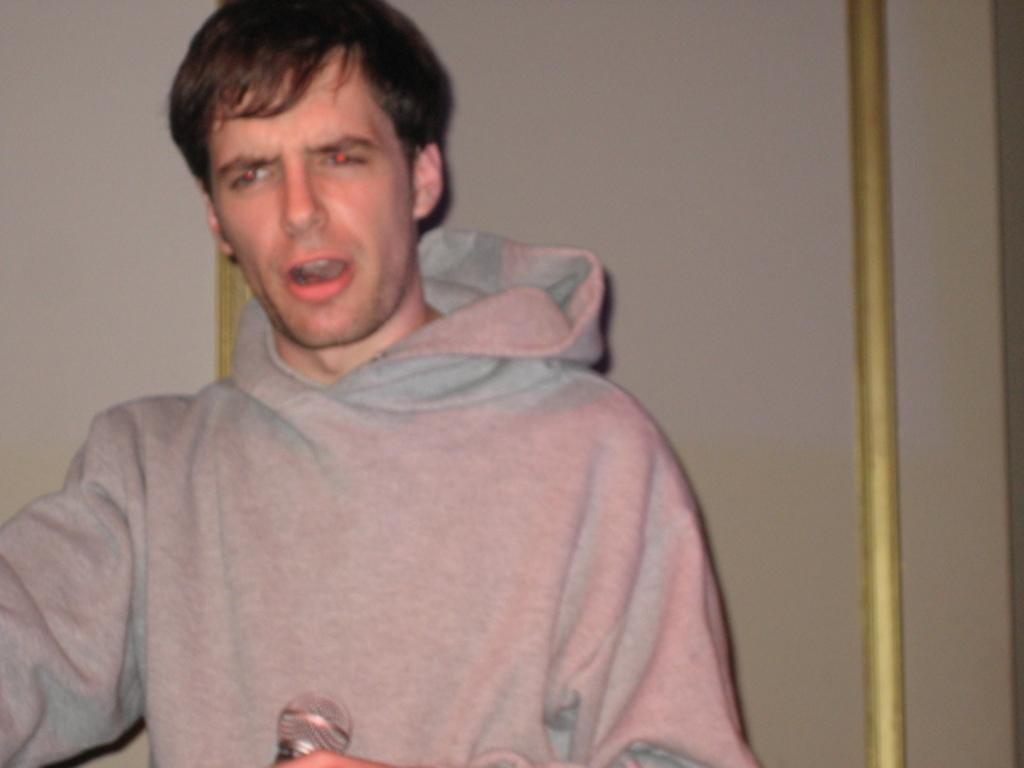Who or what is present in the image? There is a person in the image. What is the person wearing? The person is wearing an ash-colored hoodie. What object is the person holding in their hand? The person is holding a microphone in their hand. What can be seen behind the person in the image? There is a wall in the background of the image. What type of paper is the person using to create a rhythm in the image? There is no paper or rhythm-making activity present in the image. The person is simply holding a microphone. 